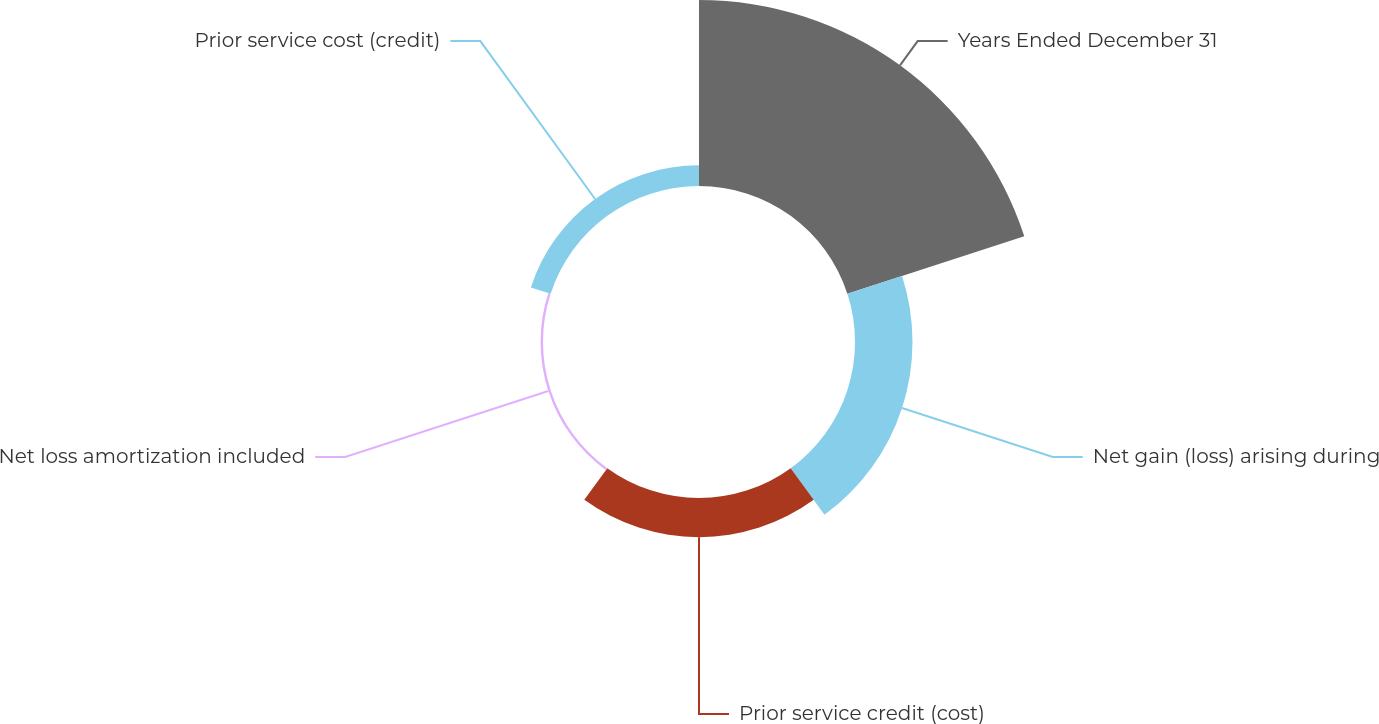Convert chart. <chart><loc_0><loc_0><loc_500><loc_500><pie_chart><fcel>Years Ended December 31<fcel>Net gain (loss) arising during<fcel>Prior service credit (cost)<fcel>Net loss amortization included<fcel>Prior service cost (credit)<nl><fcel>60.83%<fcel>18.8%<fcel>12.8%<fcel>0.79%<fcel>6.79%<nl></chart> 